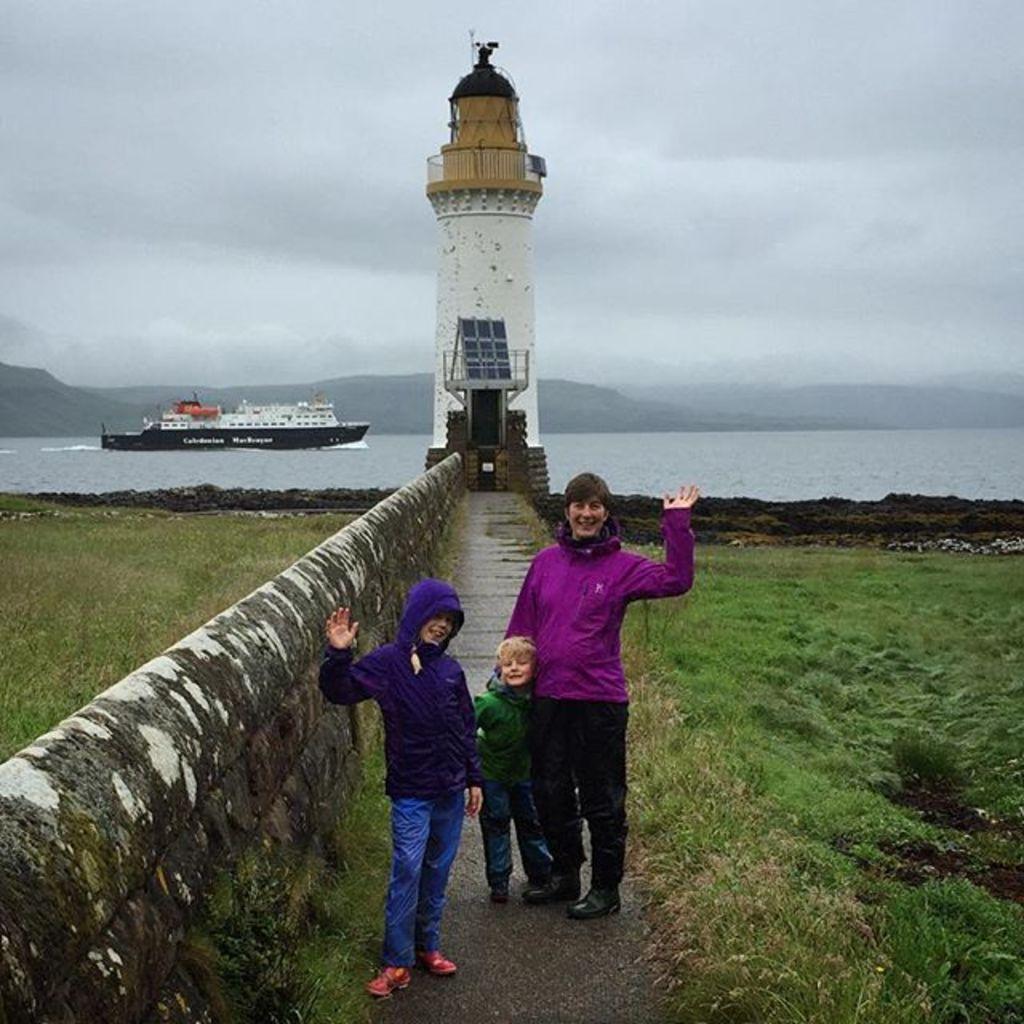Describe this image in one or two sentences. This picture might be taken from outside of the city. In this image, in the middle, we can see three people standing on the road. On the left side, we can see a ship which is drowning on the water. In the middle of the image, we can see a tower. In the background, we can see some mountains. On the top, we can see a sky which is cloudy, at the bottom, we can see a water in a ocean and a grass. 